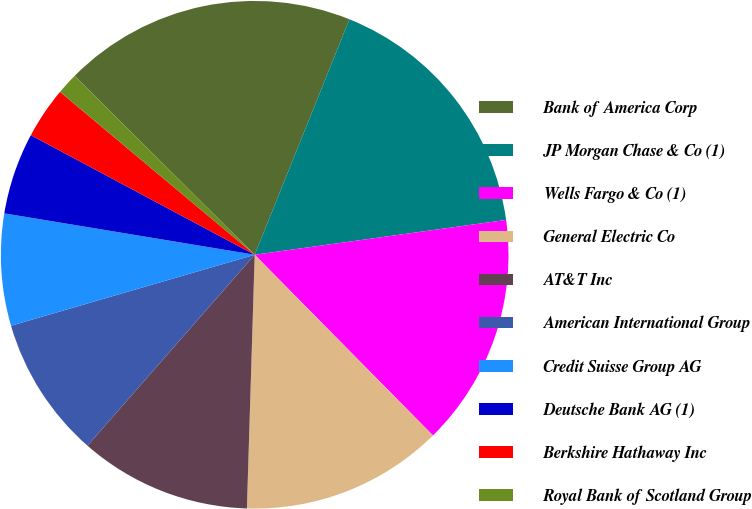Convert chart. <chart><loc_0><loc_0><loc_500><loc_500><pie_chart><fcel>Bank of America Corp<fcel>JP Morgan Chase & Co (1)<fcel>Wells Fargo & Co (1)<fcel>General Electric Co<fcel>AT&T Inc<fcel>American International Group<fcel>Credit Suisse Group AG<fcel>Deutsche Bank AG (1)<fcel>Berkshire Hathaway Inc<fcel>Royal Bank of Scotland Group<nl><fcel>18.64%<fcel>16.72%<fcel>14.8%<fcel>12.88%<fcel>10.96%<fcel>9.04%<fcel>7.12%<fcel>5.2%<fcel>3.28%<fcel>1.36%<nl></chart> 